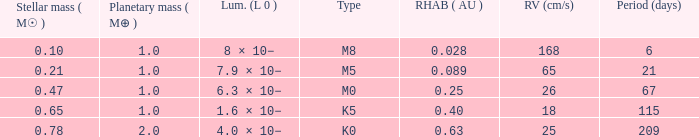In terms of days, what is the briefest period for a planet with a mass of 1, a stellar mass more than 0.21, and an m0 classification? 67.0. 